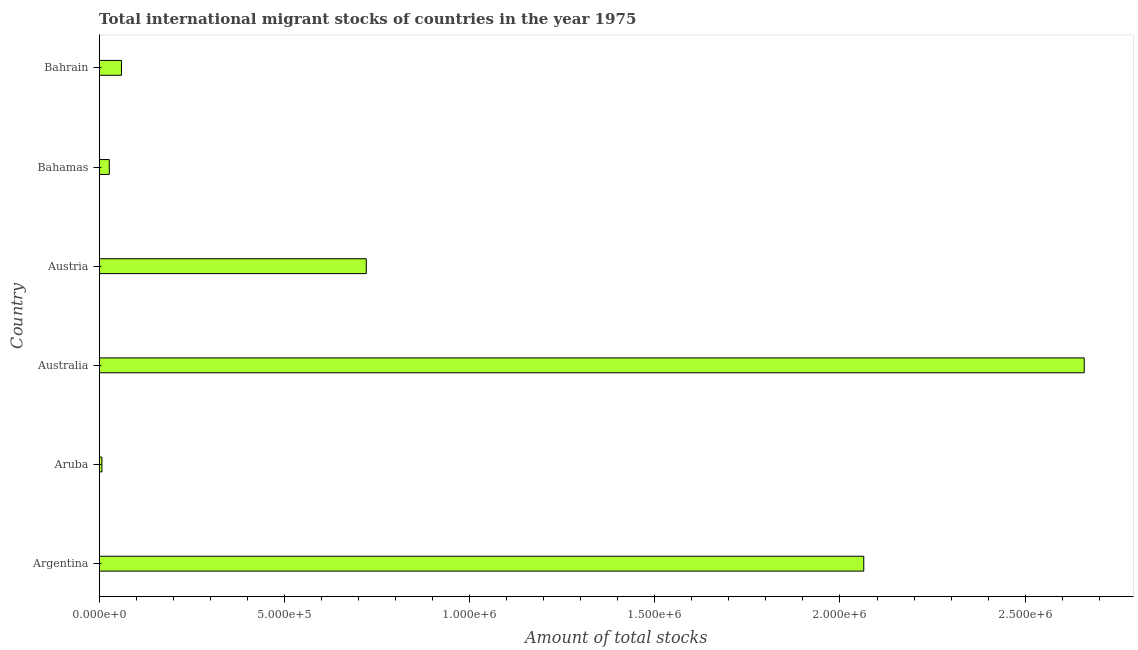What is the title of the graph?
Offer a very short reply. Total international migrant stocks of countries in the year 1975. What is the label or title of the X-axis?
Keep it short and to the point. Amount of total stocks. What is the label or title of the Y-axis?
Ensure brevity in your answer.  Country. What is the total number of international migrant stock in Austria?
Ensure brevity in your answer.  7.21e+05. Across all countries, what is the maximum total number of international migrant stock?
Your answer should be very brief. 2.66e+06. Across all countries, what is the minimum total number of international migrant stock?
Keep it short and to the point. 7262. In which country was the total number of international migrant stock minimum?
Your response must be concise. Aruba. What is the sum of the total number of international migrant stock?
Ensure brevity in your answer.  5.54e+06. What is the difference between the total number of international migrant stock in Argentina and Bahrain?
Provide a short and direct response. 2.00e+06. What is the average total number of international migrant stock per country?
Give a very brief answer. 9.23e+05. What is the median total number of international migrant stock?
Provide a succinct answer. 3.91e+05. Is the difference between the total number of international migrant stock in Argentina and Bahrain greater than the difference between any two countries?
Keep it short and to the point. No. What is the difference between the highest and the second highest total number of international migrant stock?
Your answer should be very brief. 5.95e+05. Is the sum of the total number of international migrant stock in Aruba and Bahamas greater than the maximum total number of international migrant stock across all countries?
Your response must be concise. No. What is the difference between the highest and the lowest total number of international migrant stock?
Give a very brief answer. 2.65e+06. In how many countries, is the total number of international migrant stock greater than the average total number of international migrant stock taken over all countries?
Make the answer very short. 2. Are all the bars in the graph horizontal?
Ensure brevity in your answer.  Yes. What is the difference between two consecutive major ticks on the X-axis?
Offer a terse response. 5.00e+05. Are the values on the major ticks of X-axis written in scientific E-notation?
Provide a short and direct response. Yes. What is the Amount of total stocks in Argentina?
Offer a very short reply. 2.06e+06. What is the Amount of total stocks of Aruba?
Your answer should be compact. 7262. What is the Amount of total stocks in Australia?
Make the answer very short. 2.66e+06. What is the Amount of total stocks in Austria?
Your answer should be very brief. 7.21e+05. What is the Amount of total stocks in Bahamas?
Offer a very short reply. 2.72e+04. What is the Amount of total stocks of Bahrain?
Your answer should be very brief. 6.01e+04. What is the difference between the Amount of total stocks in Argentina and Aruba?
Give a very brief answer. 2.06e+06. What is the difference between the Amount of total stocks in Argentina and Australia?
Offer a terse response. -5.95e+05. What is the difference between the Amount of total stocks in Argentina and Austria?
Provide a succinct answer. 1.34e+06. What is the difference between the Amount of total stocks in Argentina and Bahamas?
Your response must be concise. 2.04e+06. What is the difference between the Amount of total stocks in Argentina and Bahrain?
Your answer should be compact. 2.00e+06. What is the difference between the Amount of total stocks in Aruba and Australia?
Offer a terse response. -2.65e+06. What is the difference between the Amount of total stocks in Aruba and Austria?
Offer a very short reply. -7.14e+05. What is the difference between the Amount of total stocks in Aruba and Bahamas?
Give a very brief answer. -2.00e+04. What is the difference between the Amount of total stocks in Aruba and Bahrain?
Give a very brief answer. -5.28e+04. What is the difference between the Amount of total stocks in Australia and Austria?
Provide a succinct answer. 1.94e+06. What is the difference between the Amount of total stocks in Australia and Bahamas?
Your answer should be very brief. 2.63e+06. What is the difference between the Amount of total stocks in Australia and Bahrain?
Give a very brief answer. 2.60e+06. What is the difference between the Amount of total stocks in Austria and Bahamas?
Your answer should be compact. 6.94e+05. What is the difference between the Amount of total stocks in Austria and Bahrain?
Give a very brief answer. 6.61e+05. What is the difference between the Amount of total stocks in Bahamas and Bahrain?
Keep it short and to the point. -3.29e+04. What is the ratio of the Amount of total stocks in Argentina to that in Aruba?
Offer a terse response. 284.25. What is the ratio of the Amount of total stocks in Argentina to that in Australia?
Your answer should be very brief. 0.78. What is the ratio of the Amount of total stocks in Argentina to that in Austria?
Offer a terse response. 2.86. What is the ratio of the Amount of total stocks in Argentina to that in Bahamas?
Make the answer very short. 75.84. What is the ratio of the Amount of total stocks in Argentina to that in Bahrain?
Provide a short and direct response. 34.35. What is the ratio of the Amount of total stocks in Aruba to that in Australia?
Give a very brief answer. 0. What is the ratio of the Amount of total stocks in Aruba to that in Austria?
Your response must be concise. 0.01. What is the ratio of the Amount of total stocks in Aruba to that in Bahamas?
Your response must be concise. 0.27. What is the ratio of the Amount of total stocks in Aruba to that in Bahrain?
Keep it short and to the point. 0.12. What is the ratio of the Amount of total stocks in Australia to that in Austria?
Give a very brief answer. 3.69. What is the ratio of the Amount of total stocks in Australia to that in Bahamas?
Your answer should be compact. 97.71. What is the ratio of the Amount of total stocks in Australia to that in Bahrain?
Your answer should be compact. 44.26. What is the ratio of the Amount of total stocks in Austria to that in Bahamas?
Offer a very short reply. 26.49. What is the ratio of the Amount of total stocks in Austria to that in Bahrain?
Keep it short and to the point. 12. What is the ratio of the Amount of total stocks in Bahamas to that in Bahrain?
Give a very brief answer. 0.45. 